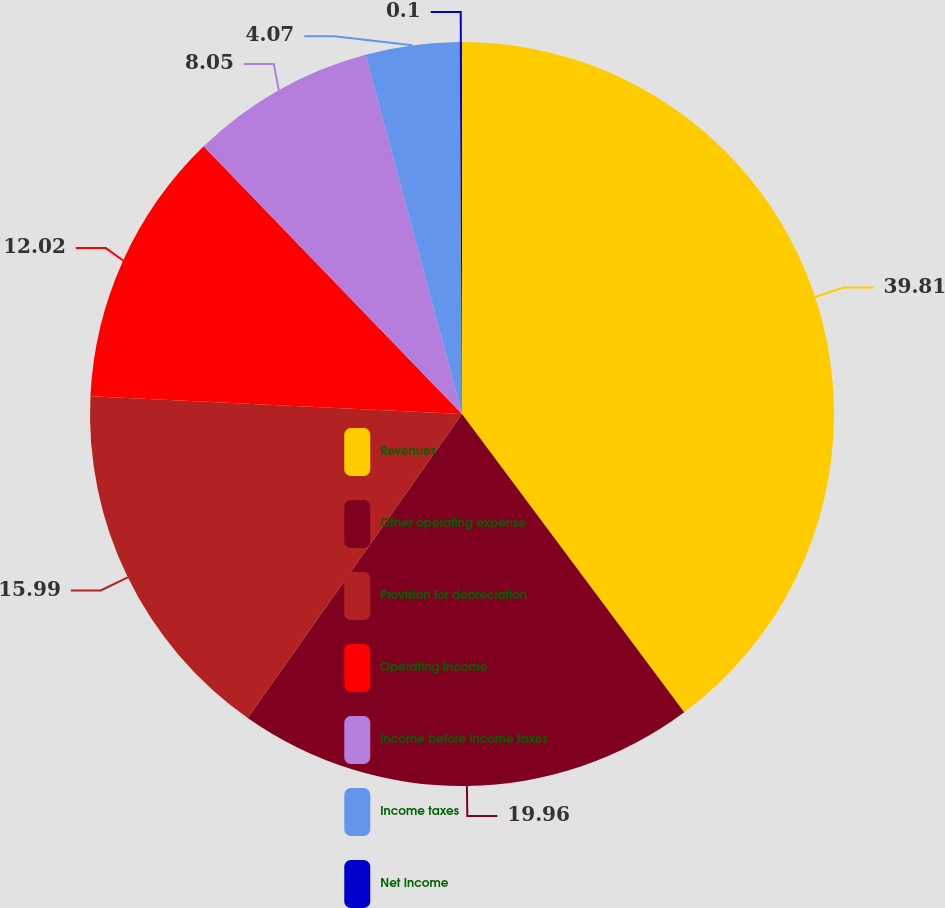Convert chart. <chart><loc_0><loc_0><loc_500><loc_500><pie_chart><fcel>Revenues<fcel>Other operating expense<fcel>Provision for depreciation<fcel>Operating Income<fcel>Income before income taxes<fcel>Income taxes<fcel>Net Income<nl><fcel>39.81%<fcel>19.96%<fcel>15.99%<fcel>12.02%<fcel>8.05%<fcel>4.07%<fcel>0.1%<nl></chart> 